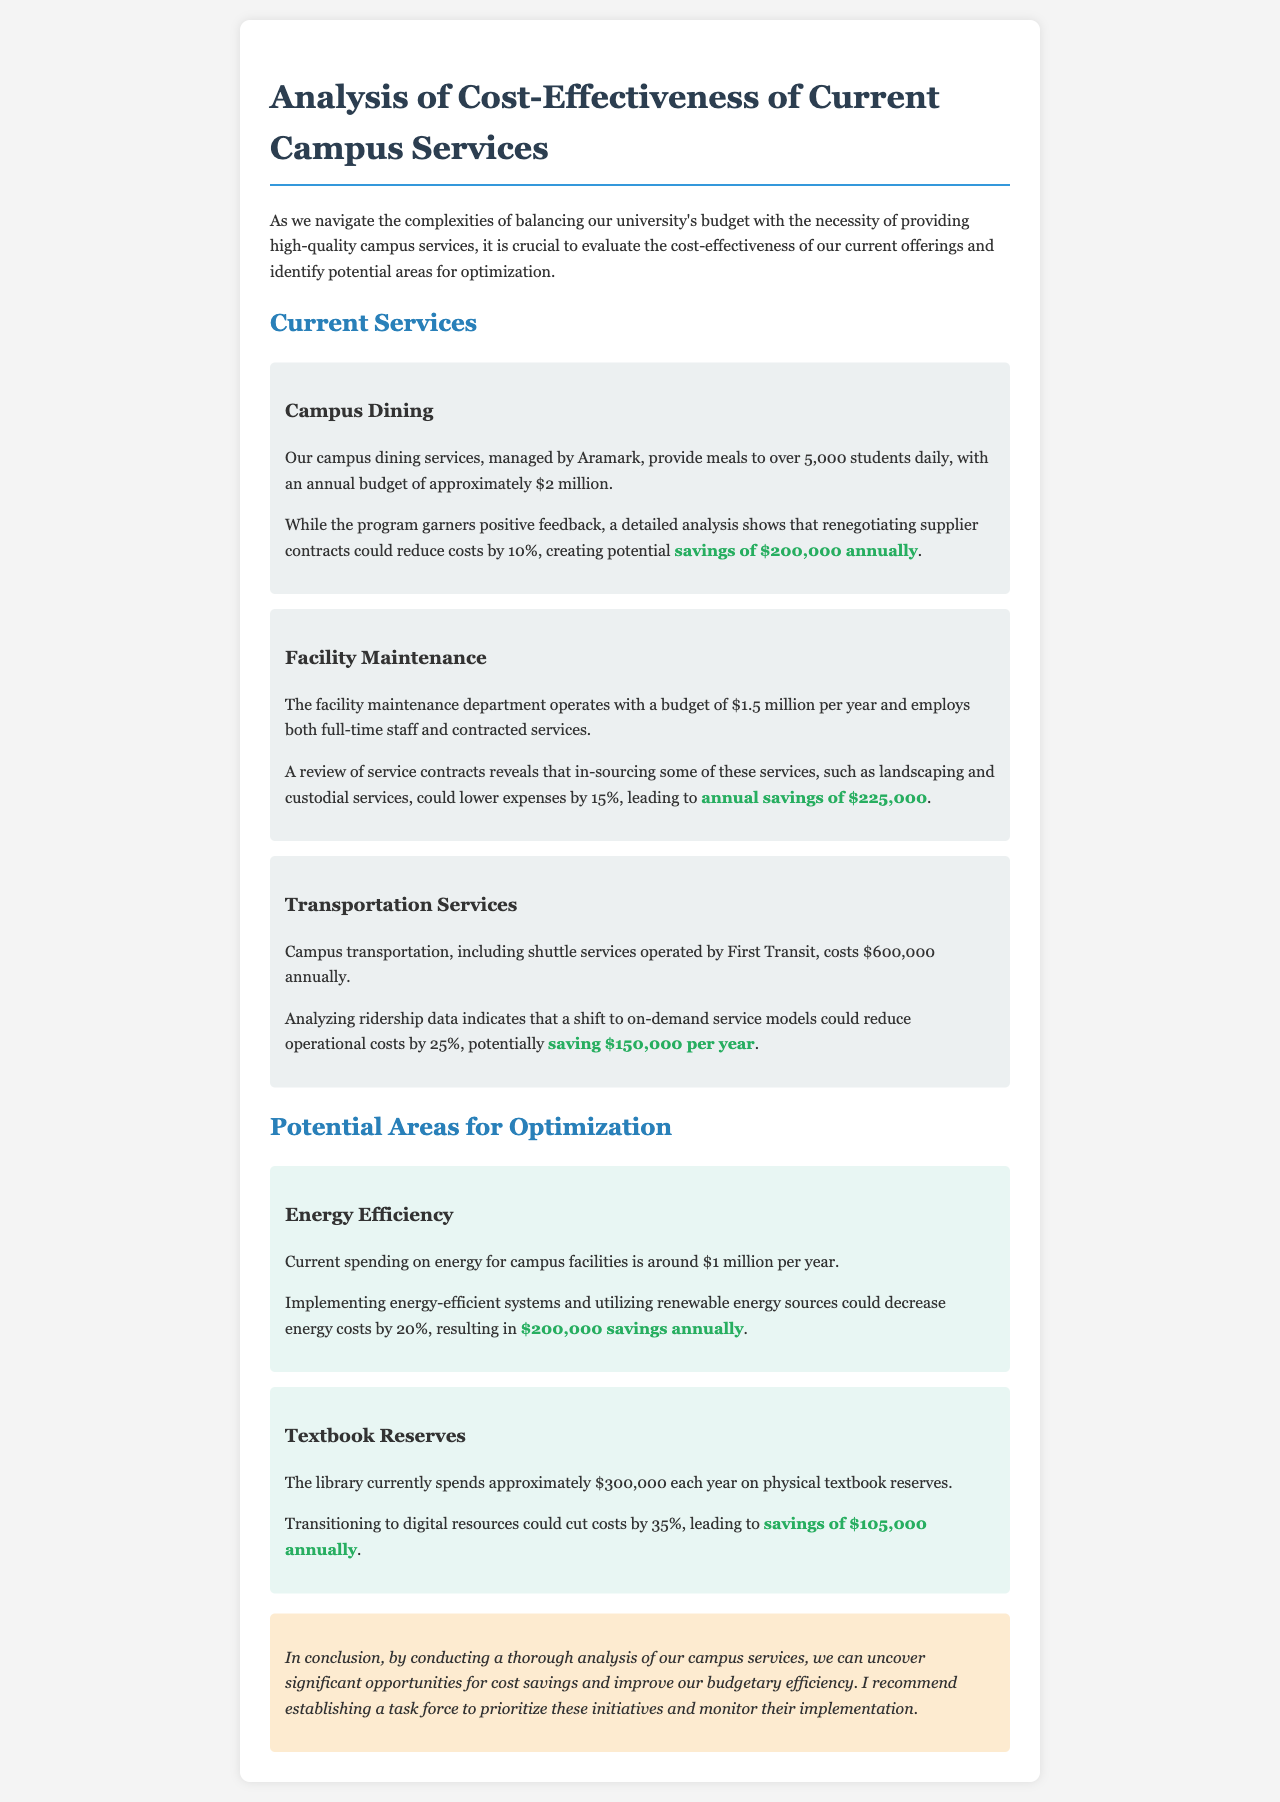What is the annual budget for campus dining services? The annual budget for campus dining services is approximately $2 million.
Answer: $2 million What percentage of cost savings is mentioned for in-sourcing facility maintenance services? The document states that in-sourcing some services could lower expenses by 15%.
Answer: 15% What is the potential annual savings from renegotiating supplier contracts for campus dining? The potential savings from renegotiating supplier contracts for campus dining is $200,000 annually.
Answer: $200,000 What is the cost of campus transportation services annually? The cost of campus transportation services is $600,000 annually.
Answer: $600,000 Which department spends approximately $300,000 each year on physical textbook reserves? The library currently spends approximately $300,000 each year on physical textbook reserves.
Answer: library Which service could potentially save $150,000 per year with an on-demand model? The campus transportation services could potentially save $150,000 per year with an on-demand model.
Answer: campus transportation services What energy cost-saving percentage is suggested for implementing energy-efficient systems? Implementing energy-efficient systems and renewable energy sources could decrease costs by 20%.
Answer: 20% What is the conclusion's recommendation regarding cost-saving initiatives? The recommendation is to establish a task force to prioritize these initiatives and monitor their implementation.
Answer: establish a task force 